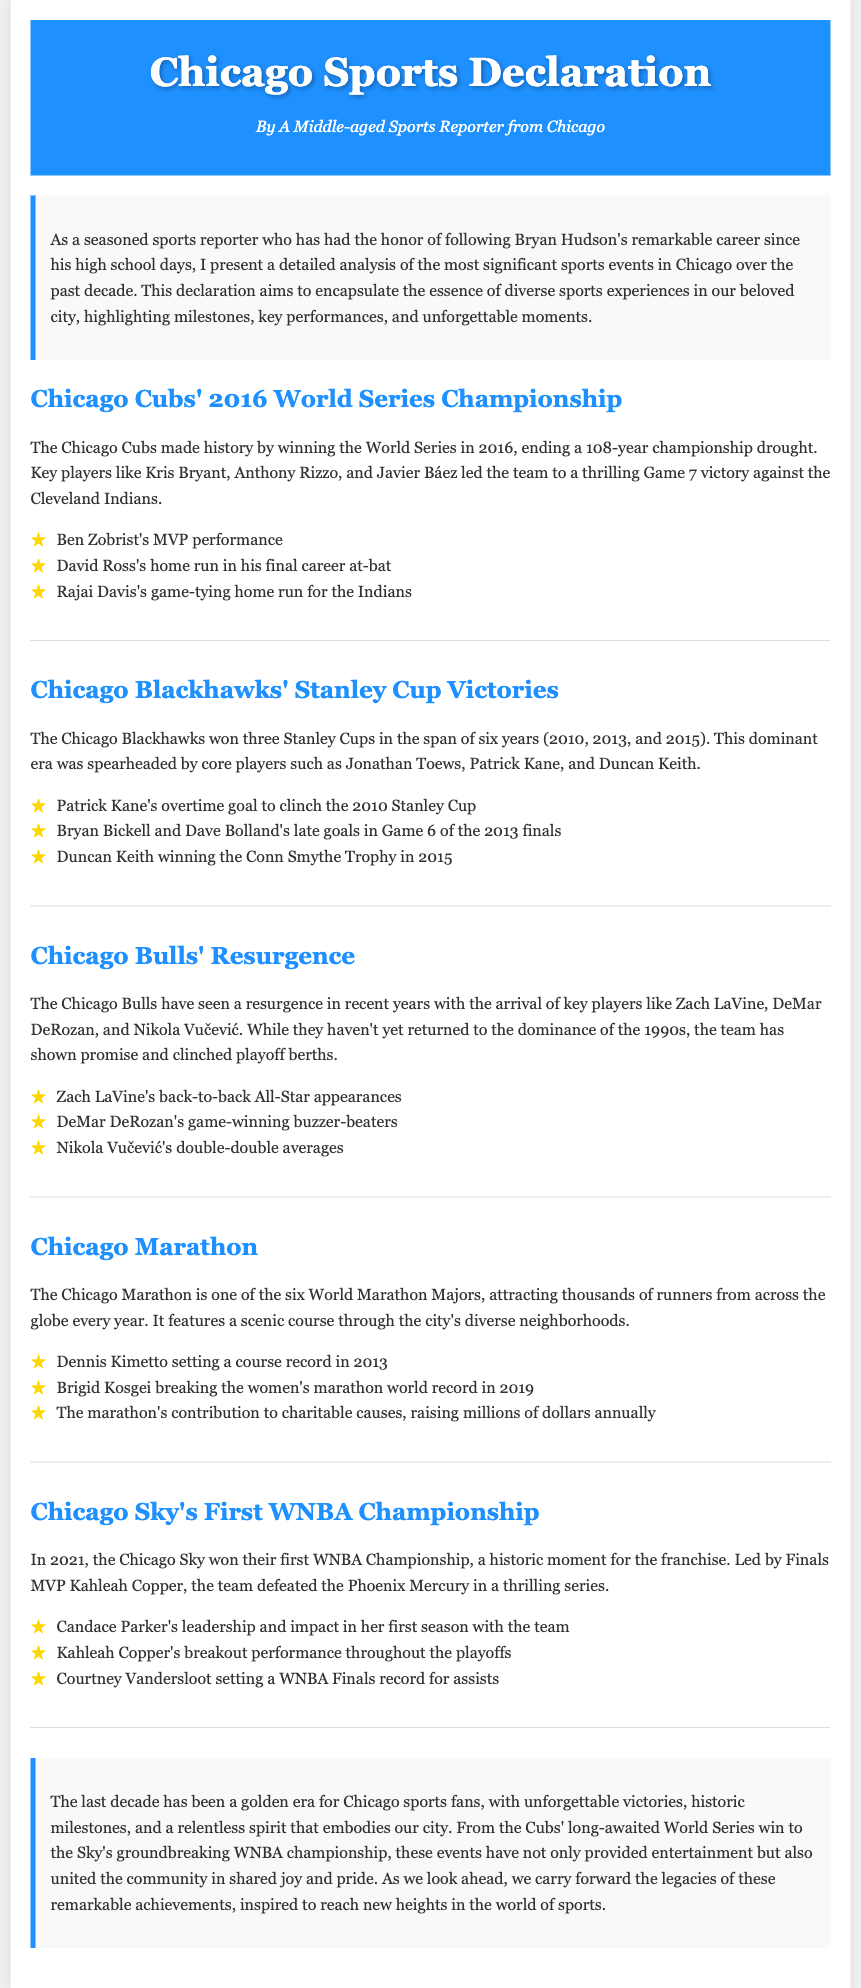What year did the Chicago Cubs win the World Series? The Chicago Cubs won the World Series in 2016, as stated in the document.
Answer: 2016 Who was named MVP in the 2016 World Series? Ben Zobrist's performance earned him the MVP title during the 2016 World Series.
Answer: Ben Zobrist How many Stanley Cups did the Chicago Blackhawks win from 2010 to 2015? The document notes that the Chicago Blackhawks won three Stanley Cups within that time frame.
Answer: Three Which player set a women’s marathon world record in 2019? Brigid Kosgei broke the women’s marathon world record in 2019, as mentioned in the document.
Answer: Brigid Kosgei What significant event did the Chicago Sky achieve in 2021? The Chicago Sky won their first WNBA Championship in 2021, according to the document.
Answer: First WNBA Championship Which player led the Chicago Sky in their 2021 championship run? Kahleah Copper was recognized as the leader of the Chicago Sky during their championship victory.
Answer: Kahleah Copper What notable performance did Patrick Kane have to clinch the 2010 Stanley Cup? Patrick Kane scored an overtime goal to win the 2010 Stanley Cup for the Blackhawks.
Answer: Overtime goal What is the document mainly about? The document provides a comprehensive analysis of major sports events in Chicago over the last decade.
Answer: Major sports events in Chicago What is highlighted as a benefit of the Chicago Marathon? The marathon's contribution to charitable causes, raising millions of dollars annually, is highlighted.
Answer: Charitable causes 